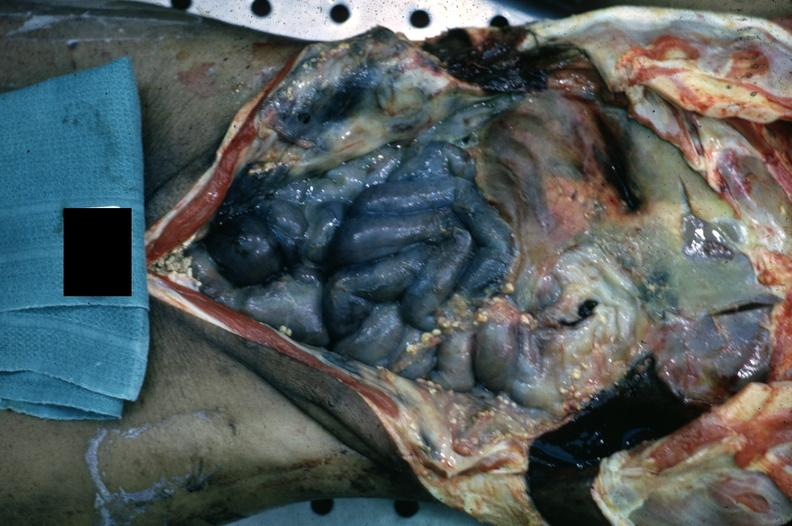s fibrinous peritonitis present?
Answer the question using a single word or phrase. Yes 